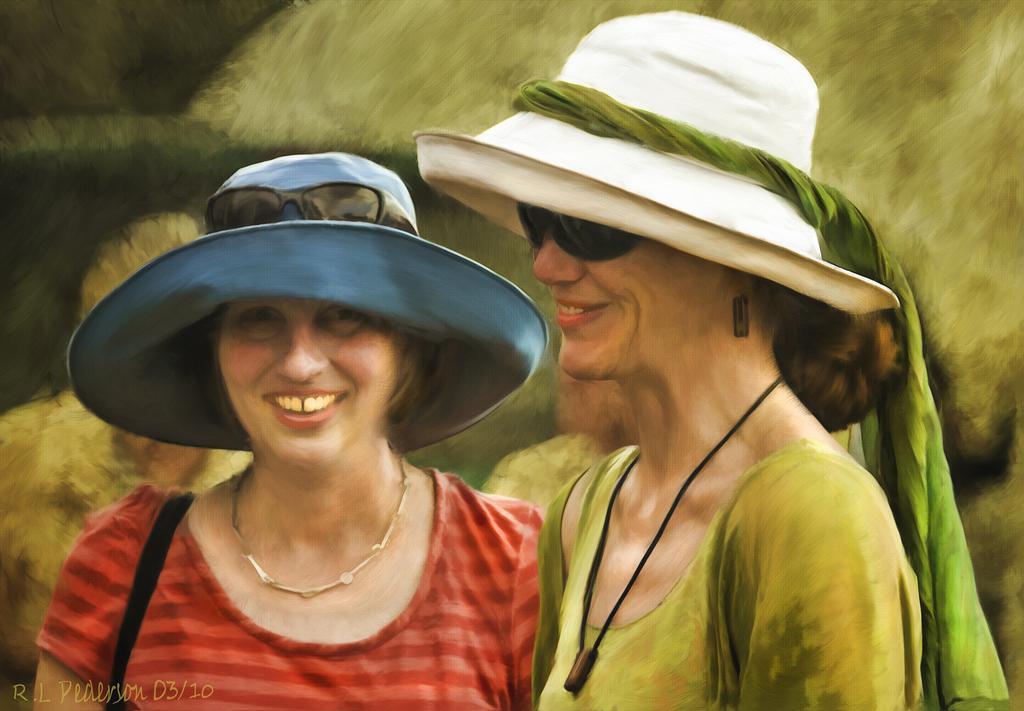How would you summarize this image in a sentence or two? It is the painting in which there are two women who are wearing the caps. 